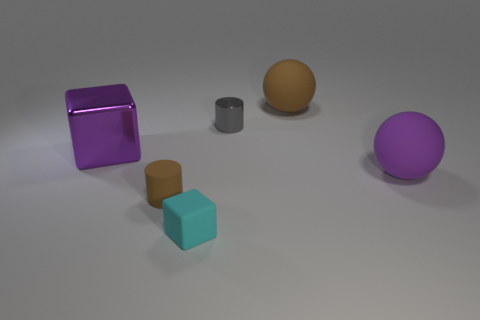There is a big sphere that is in front of the big thing behind the large metallic object; what color is it?
Provide a succinct answer. Purple. There is a purple thing that is behind the sphere in front of the rubber object that is behind the purple ball; what is its material?
Ensure brevity in your answer.  Metal. What number of metal cylinders have the same size as the purple cube?
Your answer should be compact. 0. There is a small object that is in front of the gray cylinder and behind the small cyan block; what is it made of?
Offer a terse response. Rubber. There is a big metal block; how many purple things are in front of it?
Your answer should be compact. 1. There is a small brown object; is its shape the same as the brown object right of the tiny cyan matte object?
Give a very brief answer. No. Is there a cyan rubber object of the same shape as the gray metal object?
Give a very brief answer. No. The large purple object to the right of the cylinder that is in front of the big purple matte sphere is what shape?
Give a very brief answer. Sphere. The rubber thing behind the tiny gray cylinder has what shape?
Offer a terse response. Sphere. There is a big object that is in front of the metallic block; is its color the same as the cube right of the tiny brown matte thing?
Give a very brief answer. No. 